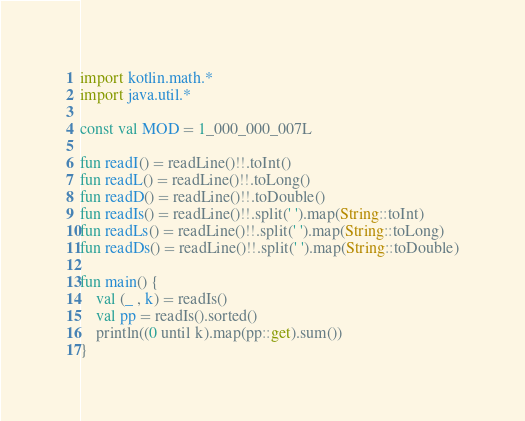Convert code to text. <code><loc_0><loc_0><loc_500><loc_500><_Kotlin_>import kotlin.math.*
import java.util.*

const val MOD = 1_000_000_007L

fun readI() = readLine()!!.toInt()
fun readL() = readLine()!!.toLong()
fun readD() = readLine()!!.toDouble()
fun readIs() = readLine()!!.split(' ').map(String::toInt)
fun readLs() = readLine()!!.split(' ').map(String::toLong)
fun readDs() = readLine()!!.split(' ').map(String::toDouble)

fun main() {
    val (_ , k) = readIs()
    val pp = readIs().sorted()
    println((0 until k).map(pp::get).sum())
}
</code> 